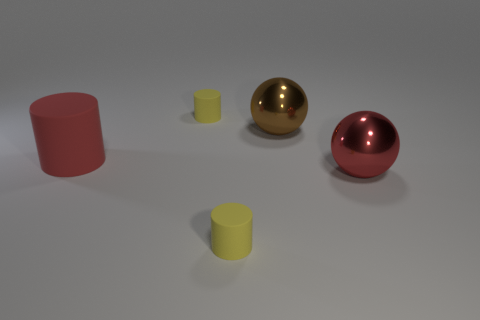What is the size of the yellow matte cylinder in front of the red matte cylinder behind the large shiny object that is to the right of the brown metallic sphere?
Ensure brevity in your answer.  Small. How many objects are the same size as the brown sphere?
Your answer should be very brief. 2. How many brown balls are there?
Your answer should be very brief. 1. Is the red cylinder made of the same material as the yellow thing that is behind the big brown sphere?
Give a very brief answer. Yes. How many red objects are either big objects or small rubber objects?
Keep it short and to the point. 2. What number of other small objects are the same shape as the red rubber object?
Offer a very short reply. 2. Is the number of large cylinders that are right of the large brown metallic thing greater than the number of red rubber things that are left of the large matte object?
Your answer should be very brief. No. Is the color of the big rubber cylinder the same as the large ball that is on the right side of the brown metallic thing?
Provide a succinct answer. Yes. What is the material of the red object that is the same size as the red ball?
Provide a succinct answer. Rubber. What number of things are brown spheres or rubber cylinders that are to the left of the big brown object?
Provide a short and direct response. 4. 